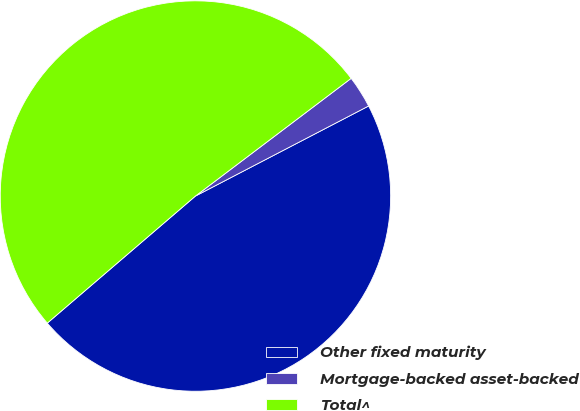Convert chart to OTSL. <chart><loc_0><loc_0><loc_500><loc_500><pie_chart><fcel>Other fixed maturity<fcel>Mortgage-backed asset-backed<fcel>Total^<nl><fcel>46.35%<fcel>2.67%<fcel>50.98%<nl></chart> 